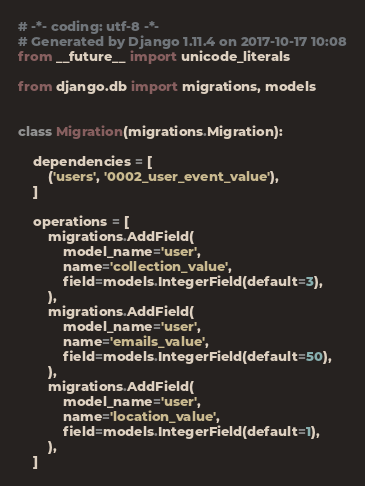Convert code to text. <code><loc_0><loc_0><loc_500><loc_500><_Python_># -*- coding: utf-8 -*-
# Generated by Django 1.11.4 on 2017-10-17 10:08
from __future__ import unicode_literals

from django.db import migrations, models


class Migration(migrations.Migration):

    dependencies = [
        ('users', '0002_user_event_value'),
    ]

    operations = [
        migrations.AddField(
            model_name='user',
            name='collection_value',
            field=models.IntegerField(default=3),
        ),
        migrations.AddField(
            model_name='user',
            name='emails_value',
            field=models.IntegerField(default=50),
        ),
        migrations.AddField(
            model_name='user',
            name='location_value',
            field=models.IntegerField(default=1),
        ),
    ]
</code> 